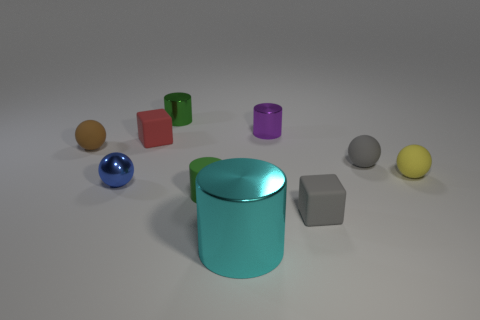There is a metallic cylinder that is the same color as the matte cylinder; what is its size?
Offer a very short reply. Small. Is the green object behind the green matte object made of the same material as the small cylinder to the right of the large cyan metal cylinder?
Give a very brief answer. Yes. Is the number of tiny balls in front of the green matte object less than the number of tiny brown matte cubes?
Keep it short and to the point. No. What number of gray rubber things are in front of the metallic object to the right of the large cyan metallic cylinder?
Your response must be concise. 2. What size is the cylinder that is in front of the red block and behind the large cyan thing?
Provide a short and direct response. Small. Is there anything else that is made of the same material as the yellow thing?
Offer a very short reply. Yes. Do the small red cube and the gray sphere behind the gray block have the same material?
Your answer should be very brief. Yes. Are there fewer cyan metallic cylinders that are behind the small red block than blue things in front of the cyan metal cylinder?
Keep it short and to the point. No. What is the material of the green cylinder that is on the right side of the tiny green metal cylinder?
Your response must be concise. Rubber. What is the color of the tiny ball that is in front of the brown matte sphere and on the left side of the big cylinder?
Your answer should be compact. Blue. 